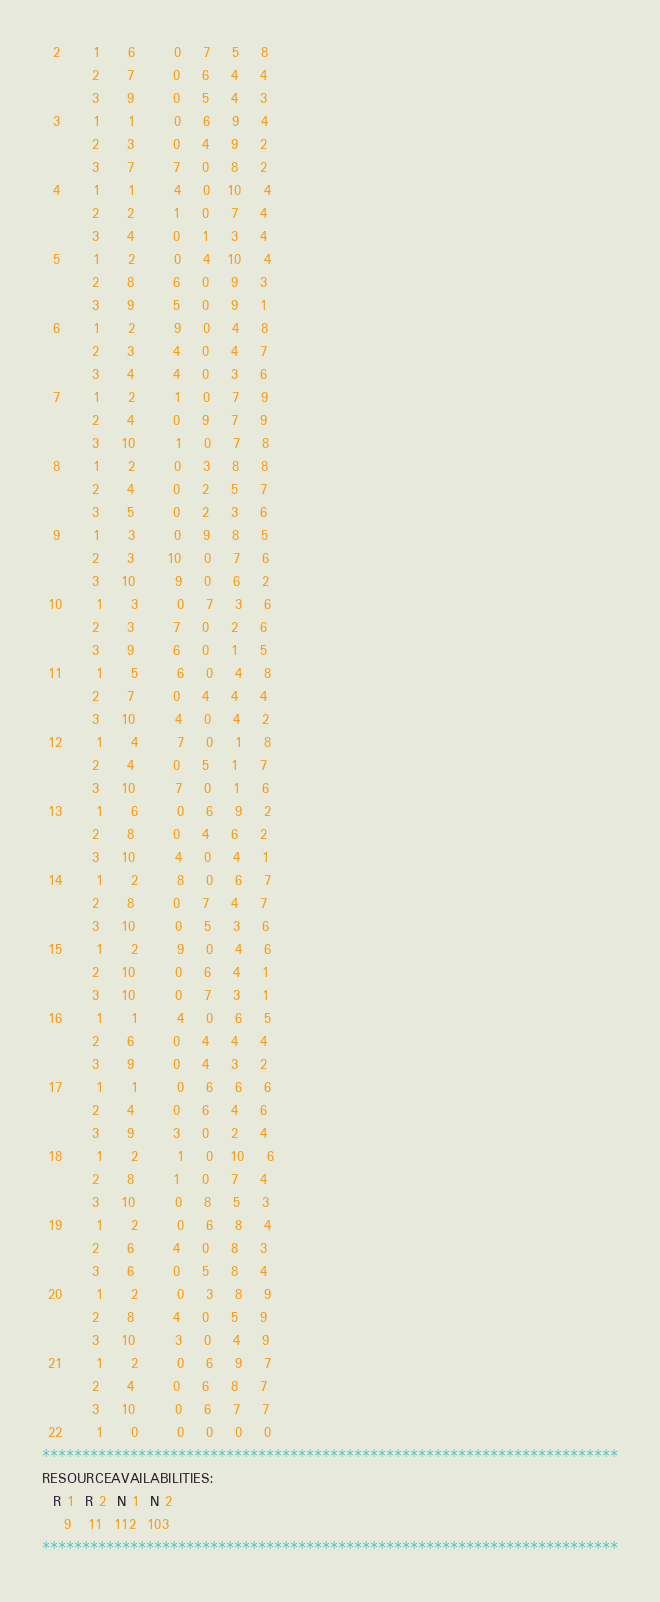<code> <loc_0><loc_0><loc_500><loc_500><_ObjectiveC_>  2      1     6       0    7    5    8
         2     7       0    6    4    4
         3     9       0    5    4    3
  3      1     1       0    6    9    4
         2     3       0    4    9    2
         3     7       7    0    8    2
  4      1     1       4    0   10    4
         2     2       1    0    7    4
         3     4       0    1    3    4
  5      1     2       0    4   10    4
         2     8       6    0    9    3
         3     9       5    0    9    1
  6      1     2       9    0    4    8
         2     3       4    0    4    7
         3     4       4    0    3    6
  7      1     2       1    0    7    9
         2     4       0    9    7    9
         3    10       1    0    7    8
  8      1     2       0    3    8    8
         2     4       0    2    5    7
         3     5       0    2    3    6
  9      1     3       0    9    8    5
         2     3      10    0    7    6
         3    10       9    0    6    2
 10      1     3       0    7    3    6
         2     3       7    0    2    6
         3     9       6    0    1    5
 11      1     5       6    0    4    8
         2     7       0    4    4    4
         3    10       4    0    4    2
 12      1     4       7    0    1    8
         2     4       0    5    1    7
         3    10       7    0    1    6
 13      1     6       0    6    9    2
         2     8       0    4    6    2
         3    10       4    0    4    1
 14      1     2       8    0    6    7
         2     8       0    7    4    7
         3    10       0    5    3    6
 15      1     2       9    0    4    6
         2    10       0    6    4    1
         3    10       0    7    3    1
 16      1     1       4    0    6    5
         2     6       0    4    4    4
         3     9       0    4    3    2
 17      1     1       0    6    6    6
         2     4       0    6    4    6
         3     9       3    0    2    4
 18      1     2       1    0   10    6
         2     8       1    0    7    4
         3    10       0    8    5    3
 19      1     2       0    6    8    4
         2     6       4    0    8    3
         3     6       0    5    8    4
 20      1     2       0    3    8    9
         2     8       4    0    5    9
         3    10       3    0    4    9
 21      1     2       0    6    9    7
         2     4       0    6    8    7
         3    10       0    6    7    7
 22      1     0       0    0    0    0
************************************************************************
RESOURCEAVAILABILITIES:
  R 1  R 2  N 1  N 2
    9   11  112  103
************************************************************************
</code> 